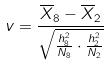Convert formula to latex. <formula><loc_0><loc_0><loc_500><loc_500>v = \frac { \overline { X } _ { 8 } - \overline { X } _ { 2 } } { \sqrt { \frac { h _ { 8 } ^ { 2 } } { N _ { 8 } } \cdot \frac { h _ { 2 } ^ { 2 } } { N _ { 2 } } } }</formula> 